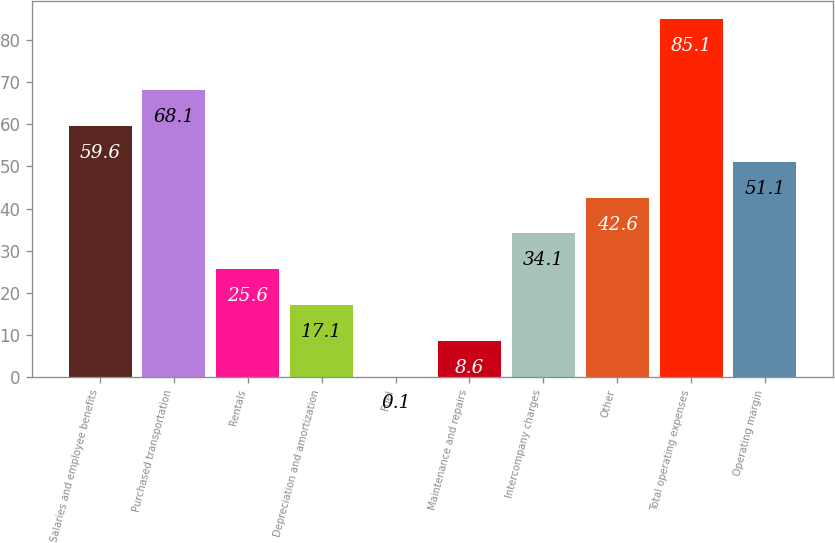<chart> <loc_0><loc_0><loc_500><loc_500><bar_chart><fcel>Salaries and employee benefits<fcel>Purchased transportation<fcel>Rentals<fcel>Depreciation and amortization<fcel>Fuel<fcel>Maintenance and repairs<fcel>Intercompany charges<fcel>Other<fcel>Total operating expenses<fcel>Operating margin<nl><fcel>59.6<fcel>68.1<fcel>25.6<fcel>17.1<fcel>0.1<fcel>8.6<fcel>34.1<fcel>42.6<fcel>85.1<fcel>51.1<nl></chart> 